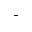Convert formula to latex. <formula><loc_0><loc_0><loc_500><loc_500>^ { + }</formula> 